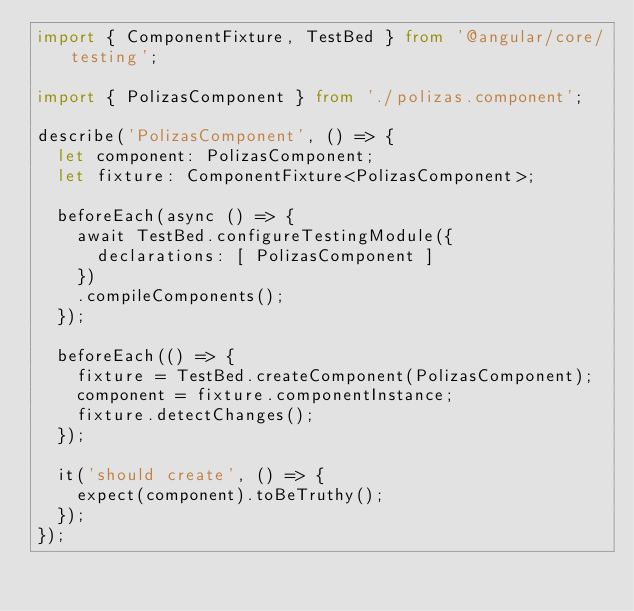<code> <loc_0><loc_0><loc_500><loc_500><_TypeScript_>import { ComponentFixture, TestBed } from '@angular/core/testing';

import { PolizasComponent } from './polizas.component';

describe('PolizasComponent', () => {
  let component: PolizasComponent;
  let fixture: ComponentFixture<PolizasComponent>;

  beforeEach(async () => {
    await TestBed.configureTestingModule({
      declarations: [ PolizasComponent ]
    })
    .compileComponents();
  });

  beforeEach(() => {
    fixture = TestBed.createComponent(PolizasComponent);
    component = fixture.componentInstance;
    fixture.detectChanges();
  });

  it('should create', () => {
    expect(component).toBeTruthy();
  });
});
</code> 